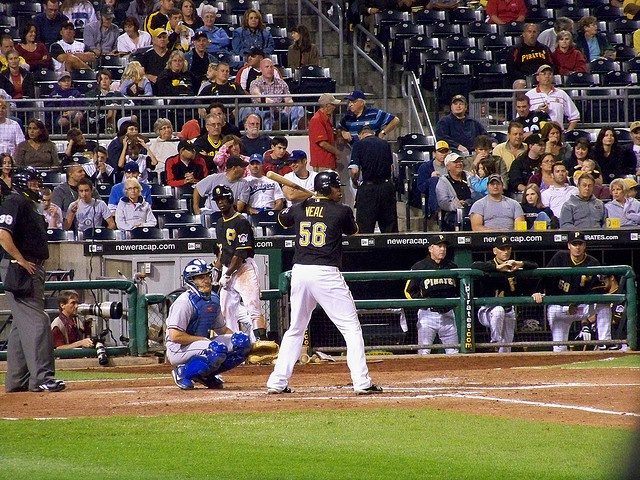Describe the objects in this image and their specific colors. I can see people in black, gray, maroon, and darkgray tones, people in black, lavender, and darkgray tones, people in black, navy, lavender, and darkblue tones, people in black, lavender, darkgray, and gray tones, and people in black, darkgray, and gray tones in this image. 